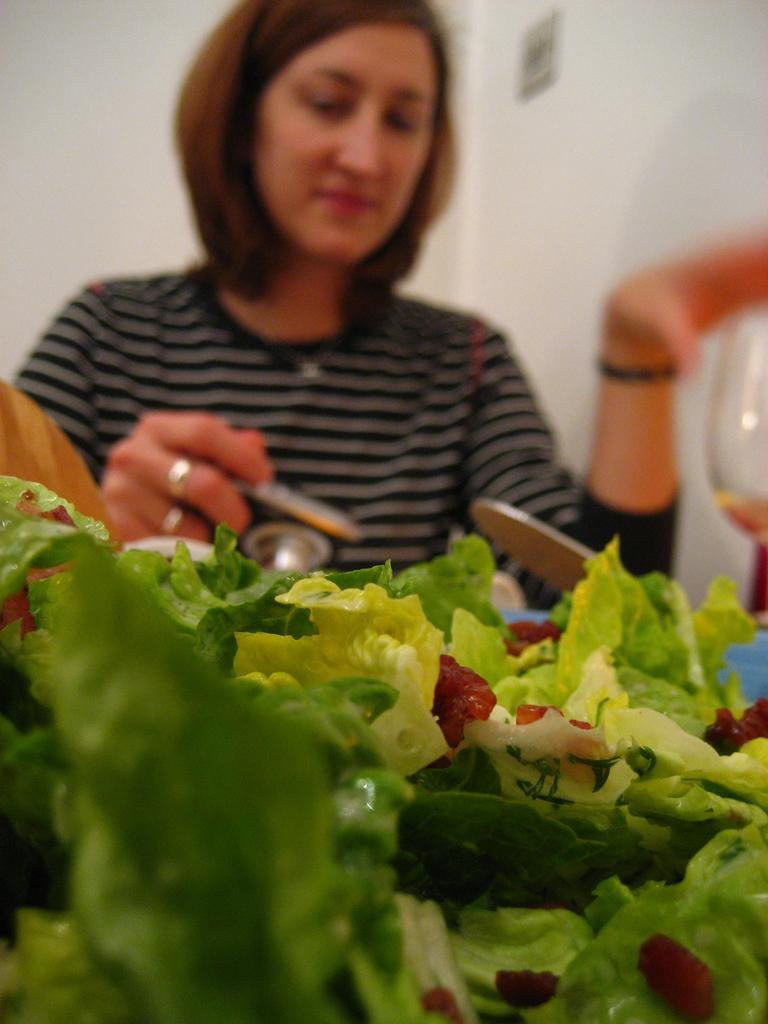What type of natural elements can be seen in the image? There are leaves in the image. What material is present in the image? There is glass in the image. Who is present in the image? There is a woman in the image. What else can be seen in the image besides the woman and the leaves? There are objects in the image. What can be seen in the background of the image? There are walls in the background of the image. What is the number of senses that can be seen in the image? There are no senses visible in the image, as senses are not physical objects that can be seen. 